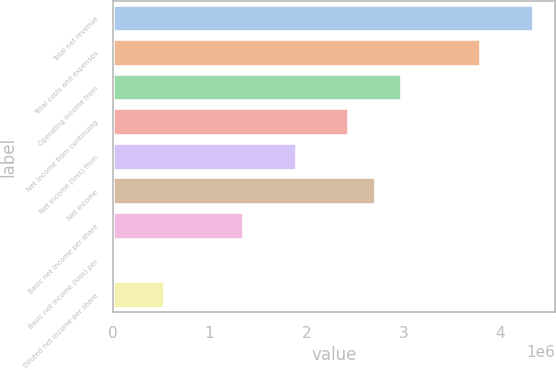Convert chart. <chart><loc_0><loc_0><loc_500><loc_500><bar_chart><fcel>Total net revenue<fcel>Total costs and expenses<fcel>Operating income from<fcel>Net income from continuing<fcel>Net income (loss) from<fcel>Net income<fcel>Basic net income per share<fcel>Basic net income (loss) per<fcel>Diluted net income per share<nl><fcel>4.34632e+06<fcel>3.80303e+06<fcel>2.9881e+06<fcel>2.44481e+06<fcel>1.90152e+06<fcel>2.71645e+06<fcel>1.35823e+06<fcel>0.02<fcel>543290<nl></chart> 